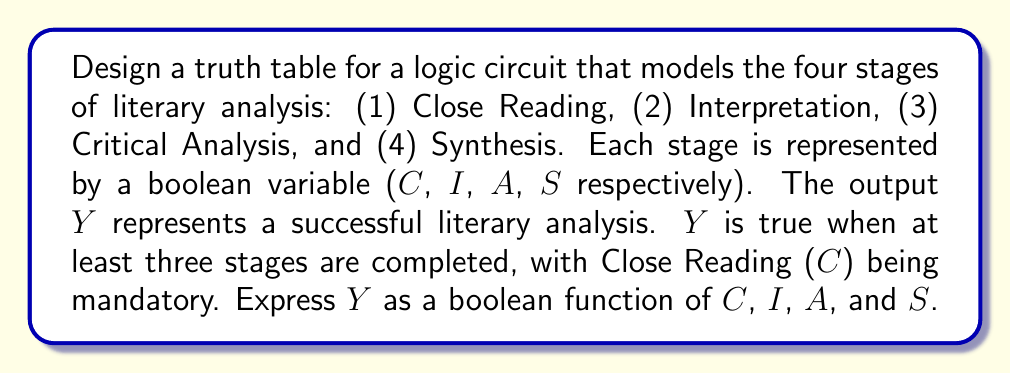Help me with this question. To solve this problem, we'll follow these steps:

1) First, we need to create a truth table with all possible combinations of C, I, A, and S.

2) We'll then determine the output Y based on the given conditions:
   - C must be true (1)
   - At least two of I, A, and S must be true

3) We'll analyze the truth table to derive the boolean function.

Truth table:

$$
\begin{array}{|c|c|c|c|c|}
\hline
C & I & A & S & Y \\
\hline
0 & 0 & 0 & 0 & 0 \\
0 & 0 & 0 & 1 & 0 \\
0 & 0 & 1 & 0 & 0 \\
0 & 0 & 1 & 1 & 0 \\
0 & 1 & 0 & 0 & 0 \\
0 & 1 & 0 & 1 & 0 \\
0 & 1 & 1 & 0 & 0 \\
0 & 1 & 1 & 1 & 0 \\
1 & 0 & 0 & 0 & 0 \\
1 & 0 & 0 & 1 & 0 \\
1 & 0 & 1 & 0 & 0 \\
1 & 0 & 1 & 1 & 1 \\
1 & 1 & 0 & 0 & 0 \\
1 & 1 & 0 & 1 & 1 \\
1 & 1 & 1 & 0 & 1 \\
1 & 1 & 1 & 1 & 1 \\
\hline
\end{array}
$$

4) From the truth table, we can derive the boolean function:

   $Y = C \cdot (I \cdot A + I \cdot S + A \cdot S)$

5) This can be simplified to:

   $Y = C \cdot (I \cdot (A + S) + A \cdot S)$

This function ensures that C is always true and at least two of I, A, and S are true, modeling the requirements for a successful literary analysis according to our defined stages.
Answer: $Y = C \cdot (I \cdot (A + S) + A \cdot S)$ 